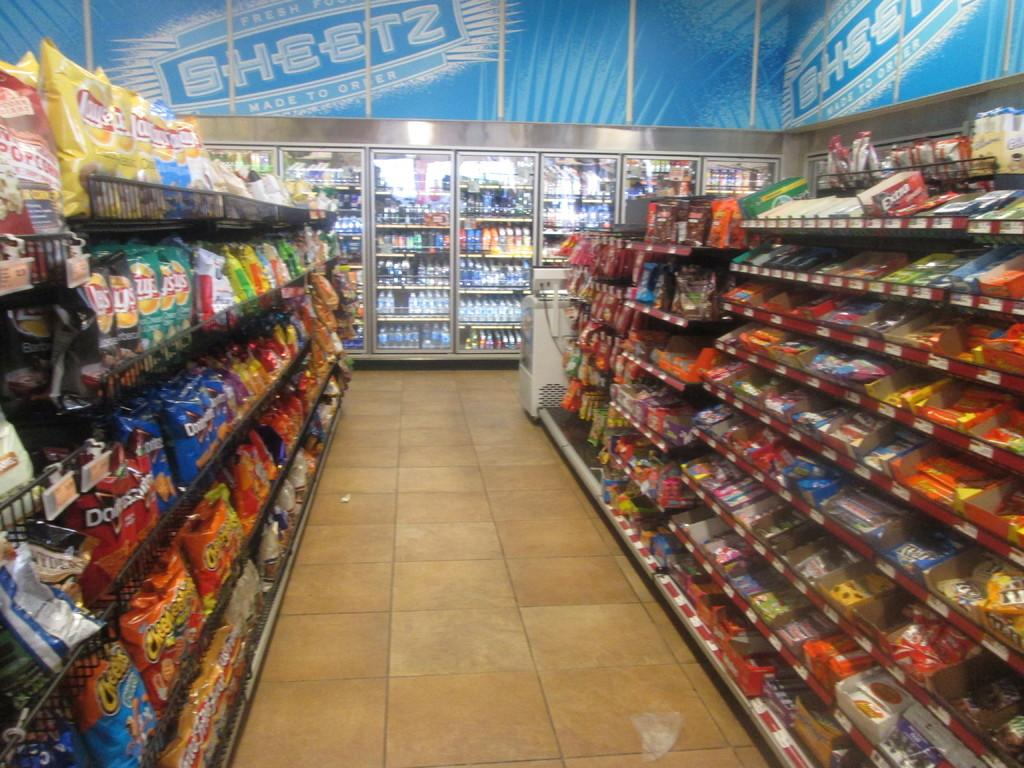<image>
Render a clear and concise summary of the photo. A snack food aisle in a Sheetz convenience store, with chips and candy. 